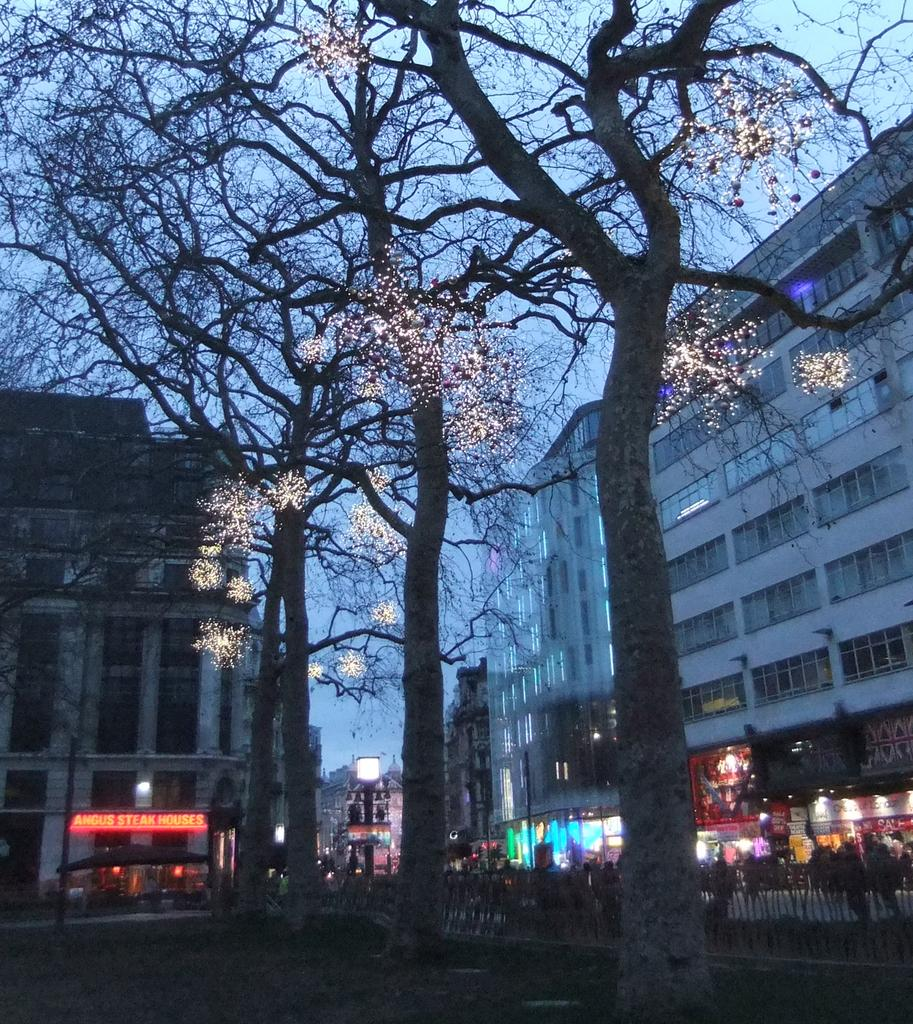What is located in the foreground of the image? There are trees with light in the foreground of the image. What can be seen in the background of the image? There are buildings and stalls in the background of the image. Is there any light visible in the background of the image? Yes, there is light visible in the background of the image. What part of the natural environment is visible in the image? The sky is visible in the background of the image. How many quarters are visible on the trees in the image? There are no quarters present on the trees in the image. What type of pickle can be seen hanging from the stalls in the image? There is no pickle present in the image; it features trees, buildings, and stalls. 